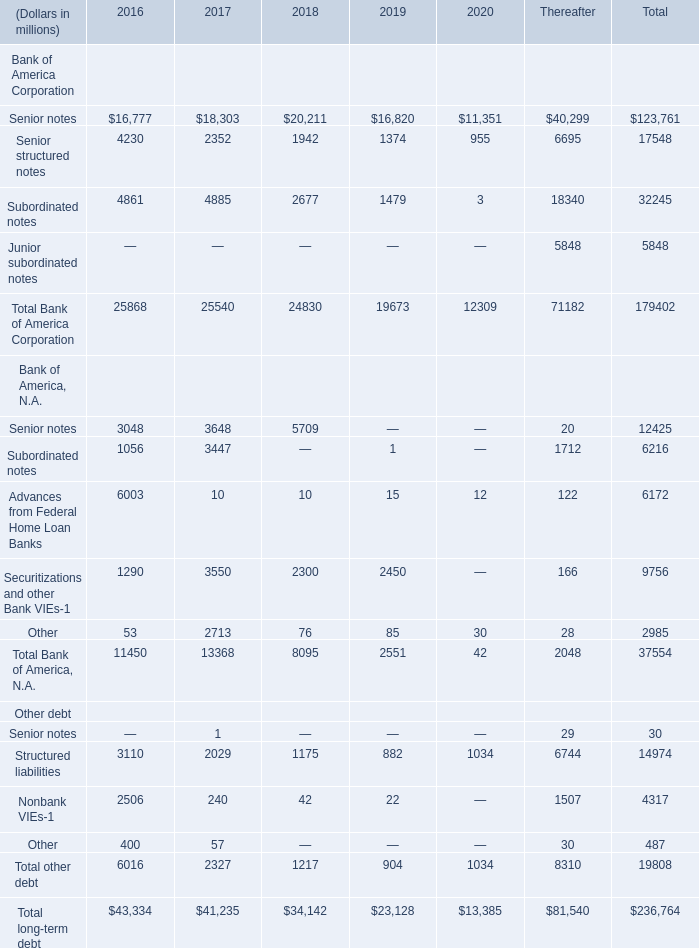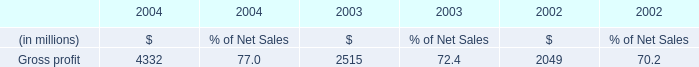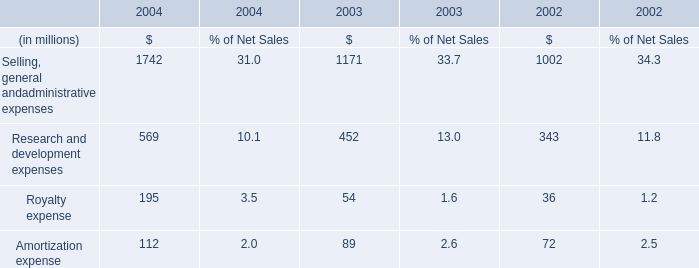what is the total amount paid in cash related to restructuring initiatives for the last three years? 
Computations: ((122.6 + 107.8) + 53.6)
Answer: 284.0. 